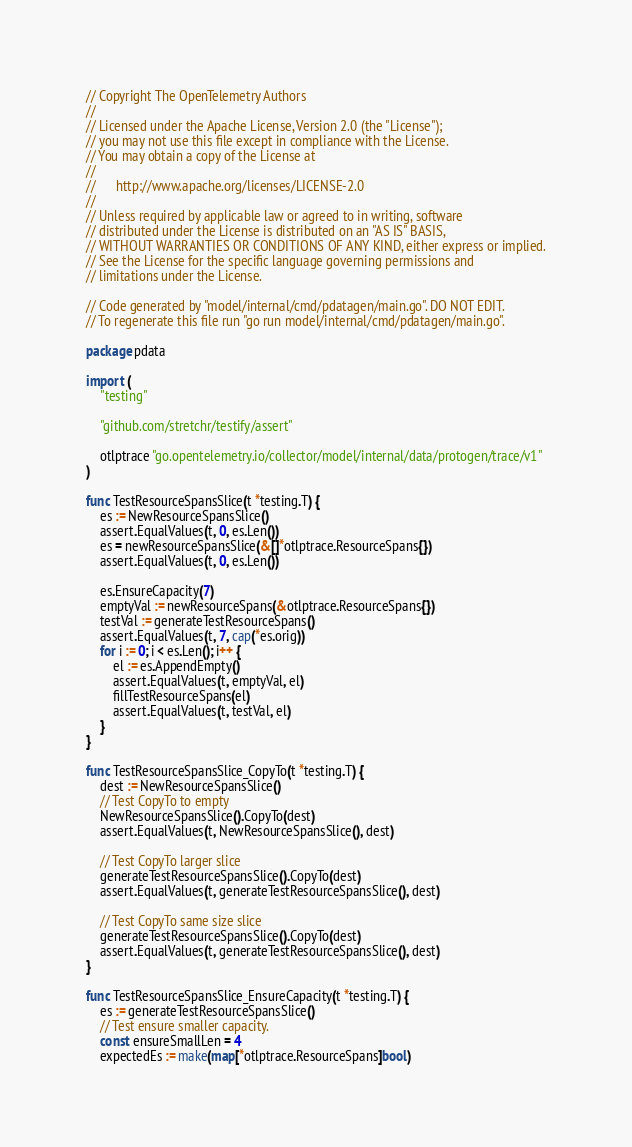<code> <loc_0><loc_0><loc_500><loc_500><_Go_>// Copyright The OpenTelemetry Authors
//
// Licensed under the Apache License, Version 2.0 (the "License");
// you may not use this file except in compliance with the License.
// You may obtain a copy of the License at
//
//      http://www.apache.org/licenses/LICENSE-2.0
//
// Unless required by applicable law or agreed to in writing, software
// distributed under the License is distributed on an "AS IS" BASIS,
// WITHOUT WARRANTIES OR CONDITIONS OF ANY KIND, either express or implied.
// See the License for the specific language governing permissions and
// limitations under the License.

// Code generated by "model/internal/cmd/pdatagen/main.go". DO NOT EDIT.
// To regenerate this file run "go run model/internal/cmd/pdatagen/main.go".

package pdata

import (
	"testing"

	"github.com/stretchr/testify/assert"

	otlptrace "go.opentelemetry.io/collector/model/internal/data/protogen/trace/v1"
)

func TestResourceSpansSlice(t *testing.T) {
	es := NewResourceSpansSlice()
	assert.EqualValues(t, 0, es.Len())
	es = newResourceSpansSlice(&[]*otlptrace.ResourceSpans{})
	assert.EqualValues(t, 0, es.Len())

	es.EnsureCapacity(7)
	emptyVal := newResourceSpans(&otlptrace.ResourceSpans{})
	testVal := generateTestResourceSpans()
	assert.EqualValues(t, 7, cap(*es.orig))
	for i := 0; i < es.Len(); i++ {
		el := es.AppendEmpty()
		assert.EqualValues(t, emptyVal, el)
		fillTestResourceSpans(el)
		assert.EqualValues(t, testVal, el)
	}
}

func TestResourceSpansSlice_CopyTo(t *testing.T) {
	dest := NewResourceSpansSlice()
	// Test CopyTo to empty
	NewResourceSpansSlice().CopyTo(dest)
	assert.EqualValues(t, NewResourceSpansSlice(), dest)

	// Test CopyTo larger slice
	generateTestResourceSpansSlice().CopyTo(dest)
	assert.EqualValues(t, generateTestResourceSpansSlice(), dest)

	// Test CopyTo same size slice
	generateTestResourceSpansSlice().CopyTo(dest)
	assert.EqualValues(t, generateTestResourceSpansSlice(), dest)
}

func TestResourceSpansSlice_EnsureCapacity(t *testing.T) {
	es := generateTestResourceSpansSlice()
	// Test ensure smaller capacity.
	const ensureSmallLen = 4
	expectedEs := make(map[*otlptrace.ResourceSpans]bool)</code> 